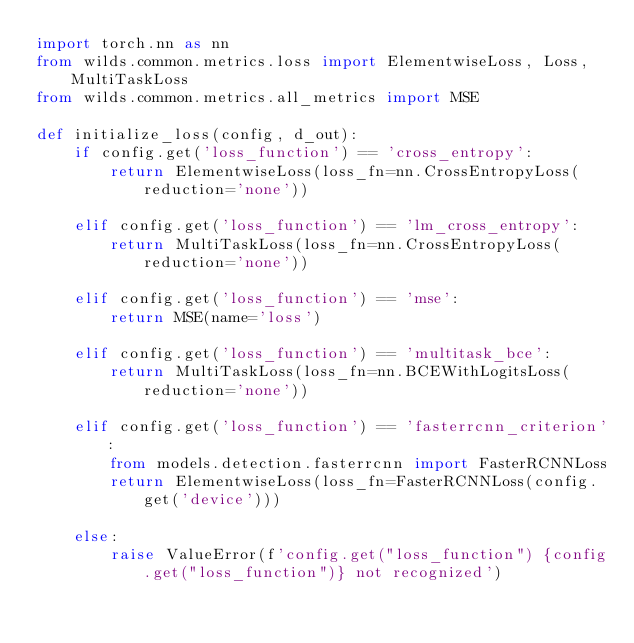<code> <loc_0><loc_0><loc_500><loc_500><_Python_>import torch.nn as nn
from wilds.common.metrics.loss import ElementwiseLoss, Loss, MultiTaskLoss
from wilds.common.metrics.all_metrics import MSE

def initialize_loss(config, d_out):
    if config.get('loss_function') == 'cross_entropy':
        return ElementwiseLoss(loss_fn=nn.CrossEntropyLoss(reduction='none'))

    elif config.get('loss_function') == 'lm_cross_entropy':
        return MultiTaskLoss(loss_fn=nn.CrossEntropyLoss(reduction='none'))

    elif config.get('loss_function') == 'mse':
        return MSE(name='loss')

    elif config.get('loss_function') == 'multitask_bce':
        return MultiTaskLoss(loss_fn=nn.BCEWithLogitsLoss(reduction='none'))

    elif config.get('loss_function') == 'fasterrcnn_criterion':
        from models.detection.fasterrcnn import FasterRCNNLoss
        return ElementwiseLoss(loss_fn=FasterRCNNLoss(config.get('device')))

    else:
        raise ValueError(f'config.get("loss_function") {config.get("loss_function")} not recognized')
</code> 